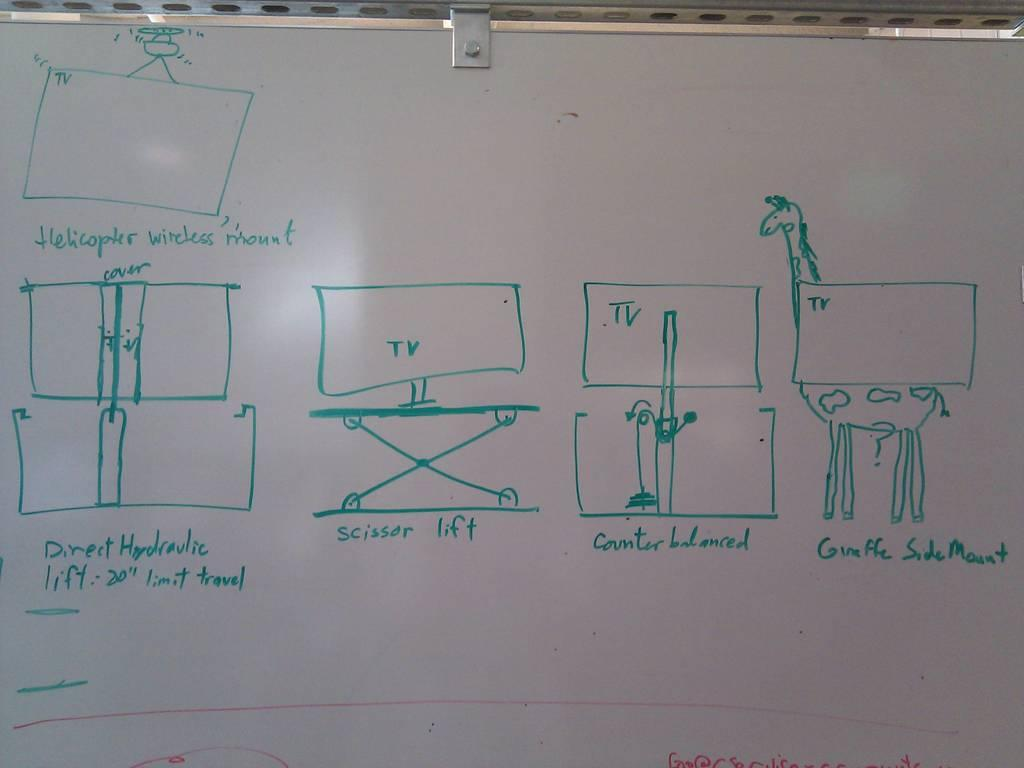<image>
Offer a succinct explanation of the picture presented. A white board has several drawings on it with one drawing labeled "scissor lift" under it. 